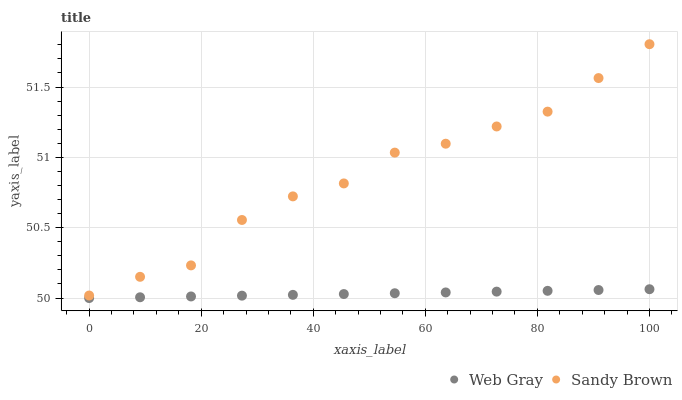Does Web Gray have the minimum area under the curve?
Answer yes or no. Yes. Does Sandy Brown have the maximum area under the curve?
Answer yes or no. Yes. Does Sandy Brown have the minimum area under the curve?
Answer yes or no. No. Is Web Gray the smoothest?
Answer yes or no. Yes. Is Sandy Brown the roughest?
Answer yes or no. Yes. Is Sandy Brown the smoothest?
Answer yes or no. No. Does Web Gray have the lowest value?
Answer yes or no. Yes. Does Sandy Brown have the lowest value?
Answer yes or no. No. Does Sandy Brown have the highest value?
Answer yes or no. Yes. Is Web Gray less than Sandy Brown?
Answer yes or no. Yes. Is Sandy Brown greater than Web Gray?
Answer yes or no. Yes. Does Web Gray intersect Sandy Brown?
Answer yes or no. No. 